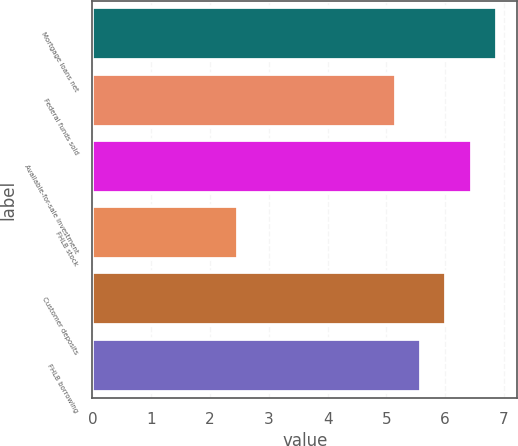Convert chart. <chart><loc_0><loc_0><loc_500><loc_500><bar_chart><fcel>Mortgage loans net<fcel>Federal funds sold<fcel>Available-for-sale investment<fcel>FHLB stock<fcel>Customer deposits<fcel>FHLB borrowing<nl><fcel>6.88<fcel>5.16<fcel>6.45<fcel>2.47<fcel>6.02<fcel>5.59<nl></chart> 